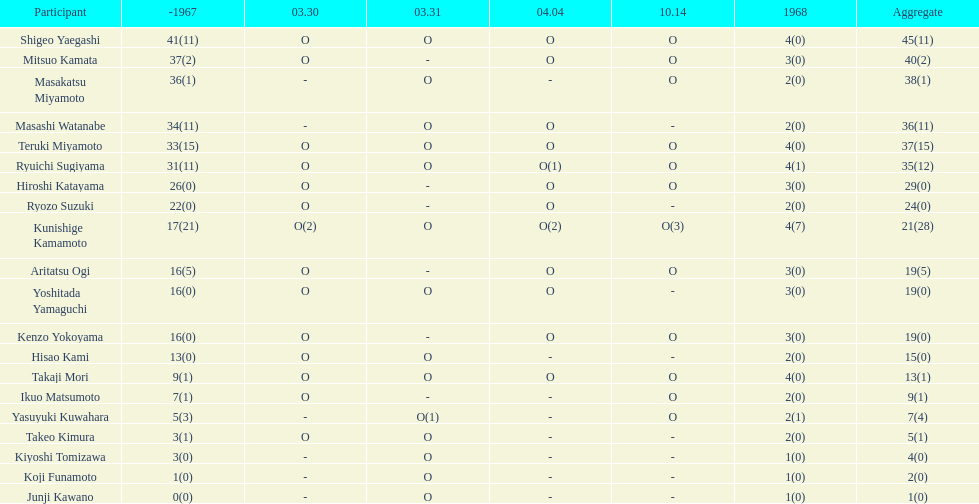Who had more points takaji mori or junji kawano? Takaji Mori. 